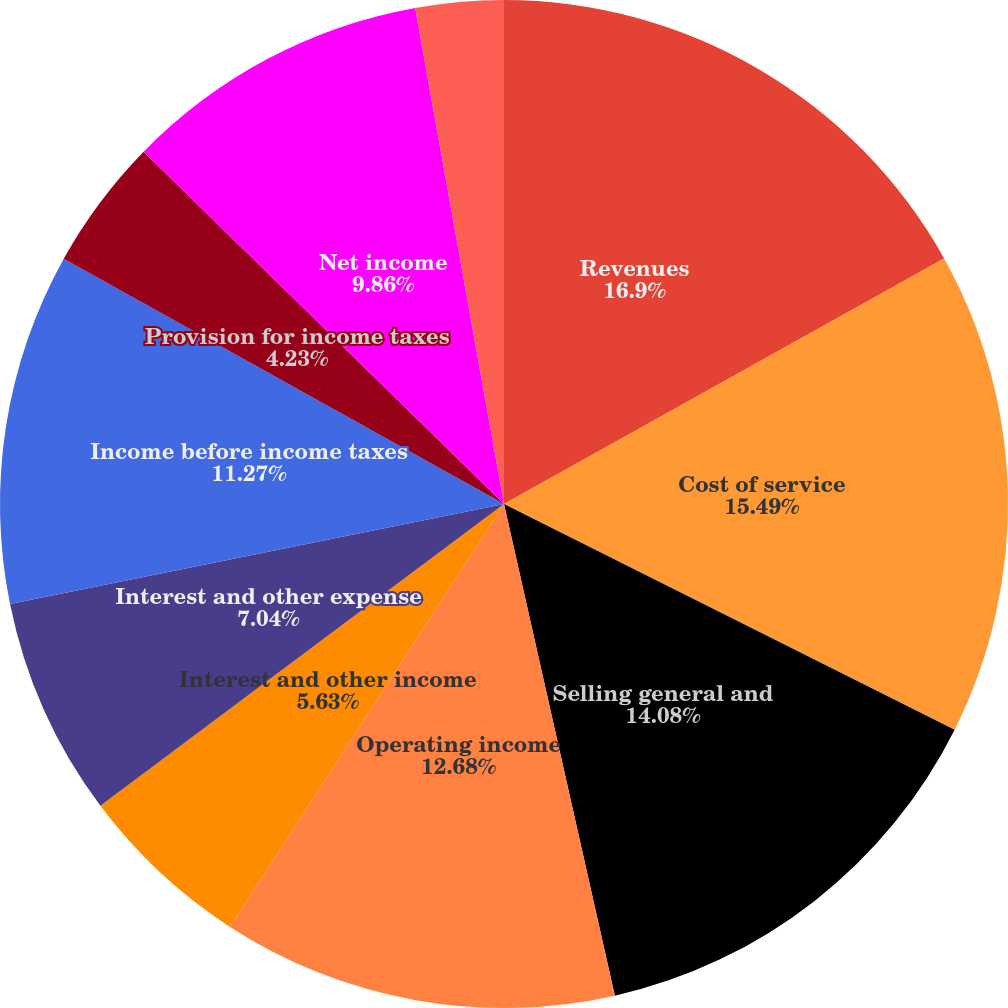<chart> <loc_0><loc_0><loc_500><loc_500><pie_chart><fcel>Revenues<fcel>Cost of service<fcel>Selling general and<fcel>Operating income<fcel>Interest and other income<fcel>Interest and other expense<fcel>Income before income taxes<fcel>Provision for income taxes<fcel>Net income<fcel>Less Net income attributable<nl><fcel>16.9%<fcel>15.49%<fcel>14.08%<fcel>12.68%<fcel>5.63%<fcel>7.04%<fcel>11.27%<fcel>4.23%<fcel>9.86%<fcel>2.82%<nl></chart> 